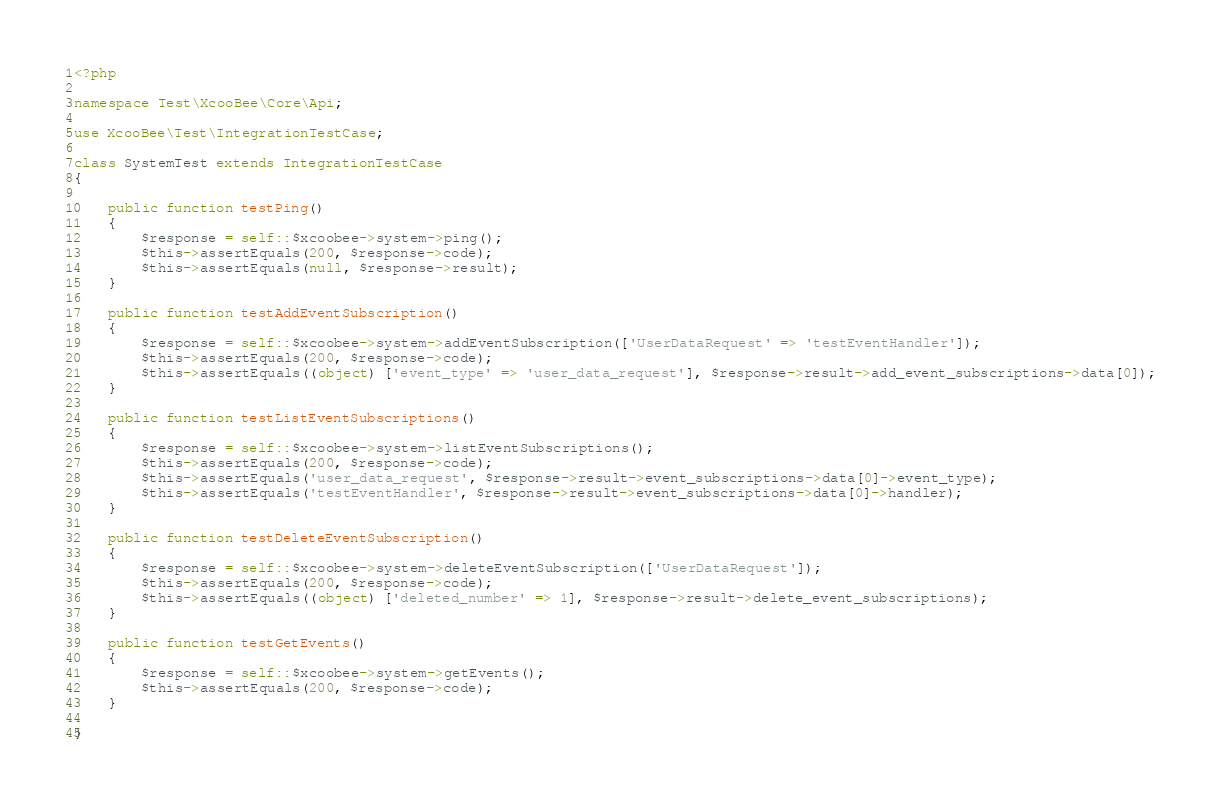<code> <loc_0><loc_0><loc_500><loc_500><_PHP_><?php

namespace Test\XcooBee\Core\Api;

use XcooBee\Test\IntegrationTestCase;

class SystemTest extends IntegrationTestCase
{

    public function testPing()
    {
        $response = self::$xcoobee->system->ping();
        $this->assertEquals(200, $response->code);
        $this->assertEquals(null, $response->result);
    }

    public function testAddEventSubscription()
    {
        $response = self::$xcoobee->system->addEventSubscription(['UserDataRequest' => 'testEventHandler']);
        $this->assertEquals(200, $response->code);
        $this->assertEquals((object) ['event_type' => 'user_data_request'], $response->result->add_event_subscriptions->data[0]);
    }
    
    public function testListEventSubscriptions()
    {
        $response = self::$xcoobee->system->listEventSubscriptions();
        $this->assertEquals(200, $response->code);
        $this->assertEquals('user_data_request', $response->result->event_subscriptions->data[0]->event_type);
        $this->assertEquals('testEventHandler', $response->result->event_subscriptions->data[0]->handler);
    }
    
    public function testDeleteEventSubscription()
    {
        $response = self::$xcoobee->system->deleteEventSubscription(['UserDataRequest']);
        $this->assertEquals(200, $response->code);
        $this->assertEquals((object) ['deleted_number' => 1], $response->result->delete_event_subscriptions);
    }

    public function testGetEvents()
    {
        $response = self::$xcoobee->system->getEvents();
        $this->assertEquals(200, $response->code);
    }

}
</code> 